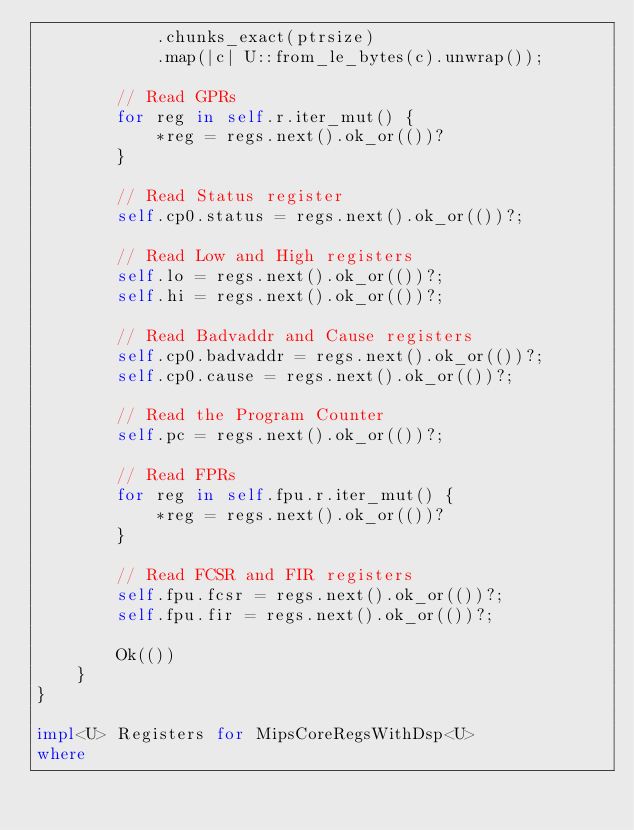Convert code to text. <code><loc_0><loc_0><loc_500><loc_500><_Rust_>            .chunks_exact(ptrsize)
            .map(|c| U::from_le_bytes(c).unwrap());

        // Read GPRs
        for reg in self.r.iter_mut() {
            *reg = regs.next().ok_or(())?
        }

        // Read Status register
        self.cp0.status = regs.next().ok_or(())?;

        // Read Low and High registers
        self.lo = regs.next().ok_or(())?;
        self.hi = regs.next().ok_or(())?;

        // Read Badvaddr and Cause registers
        self.cp0.badvaddr = regs.next().ok_or(())?;
        self.cp0.cause = regs.next().ok_or(())?;

        // Read the Program Counter
        self.pc = regs.next().ok_or(())?;

        // Read FPRs
        for reg in self.fpu.r.iter_mut() {
            *reg = regs.next().ok_or(())?
        }

        // Read FCSR and FIR registers
        self.fpu.fcsr = regs.next().ok_or(())?;
        self.fpu.fir = regs.next().ok_or(())?;

        Ok(())
    }
}

impl<U> Registers for MipsCoreRegsWithDsp<U>
where</code> 